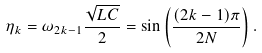Convert formula to latex. <formula><loc_0><loc_0><loc_500><loc_500>\eta _ { k } = \omega _ { 2 k - 1 } \frac { \sqrt { L C } } { 2 } = \sin \left ( \frac { ( 2 k - 1 ) \pi } { 2 N } \right ) .</formula> 